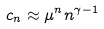<formula> <loc_0><loc_0><loc_500><loc_500>c _ { n } \approx \mu ^ { n } n ^ { \gamma - 1 }</formula> 